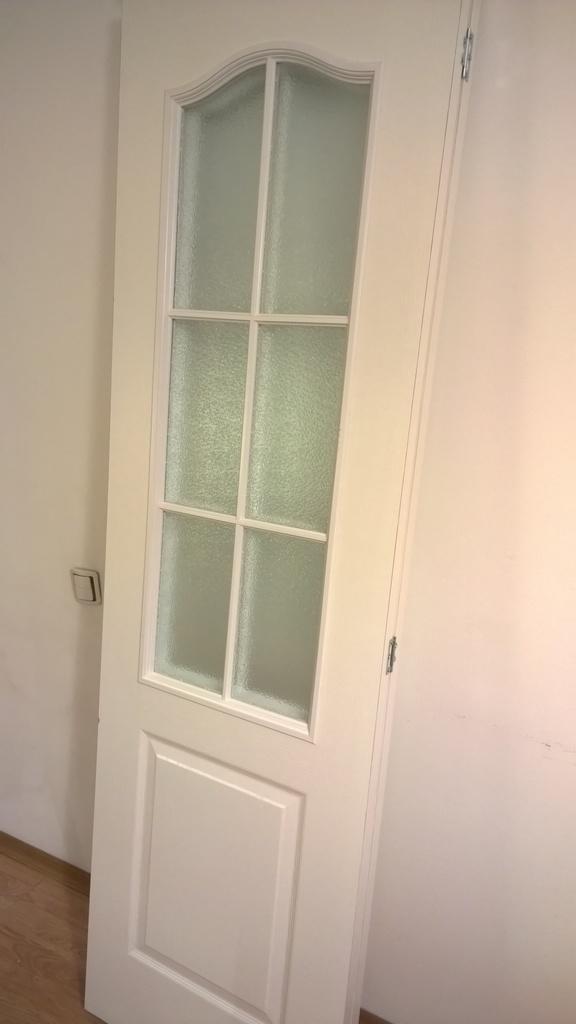Please provide a concise description of this image. In the image I can see a door to which there is a glass mirror. 